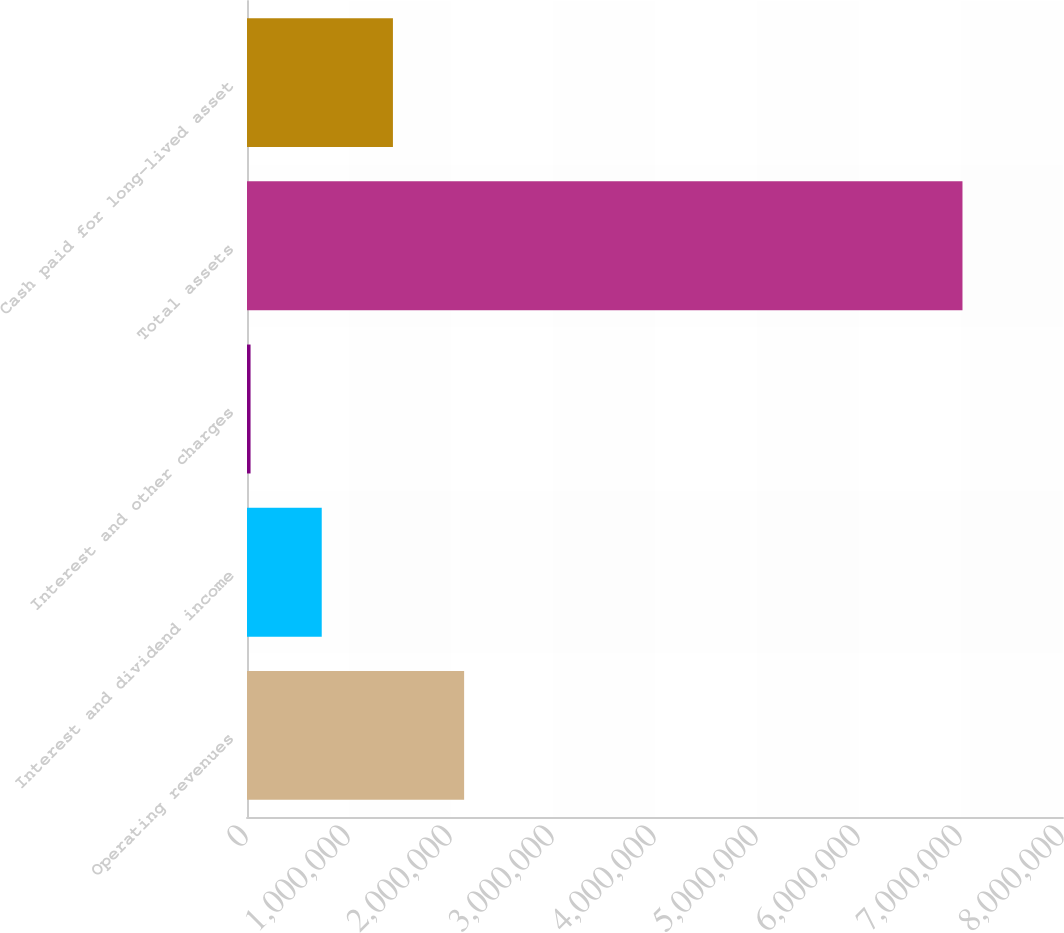<chart> <loc_0><loc_0><loc_500><loc_500><bar_chart><fcel>Operating revenues<fcel>Interest and dividend income<fcel>Interest and other charges<fcel>Total assets<fcel>Cash paid for long-lived asset<nl><fcel>2.12866e+06<fcel>732713<fcel>34738<fcel>7.01448e+06<fcel>1.43069e+06<nl></chart> 